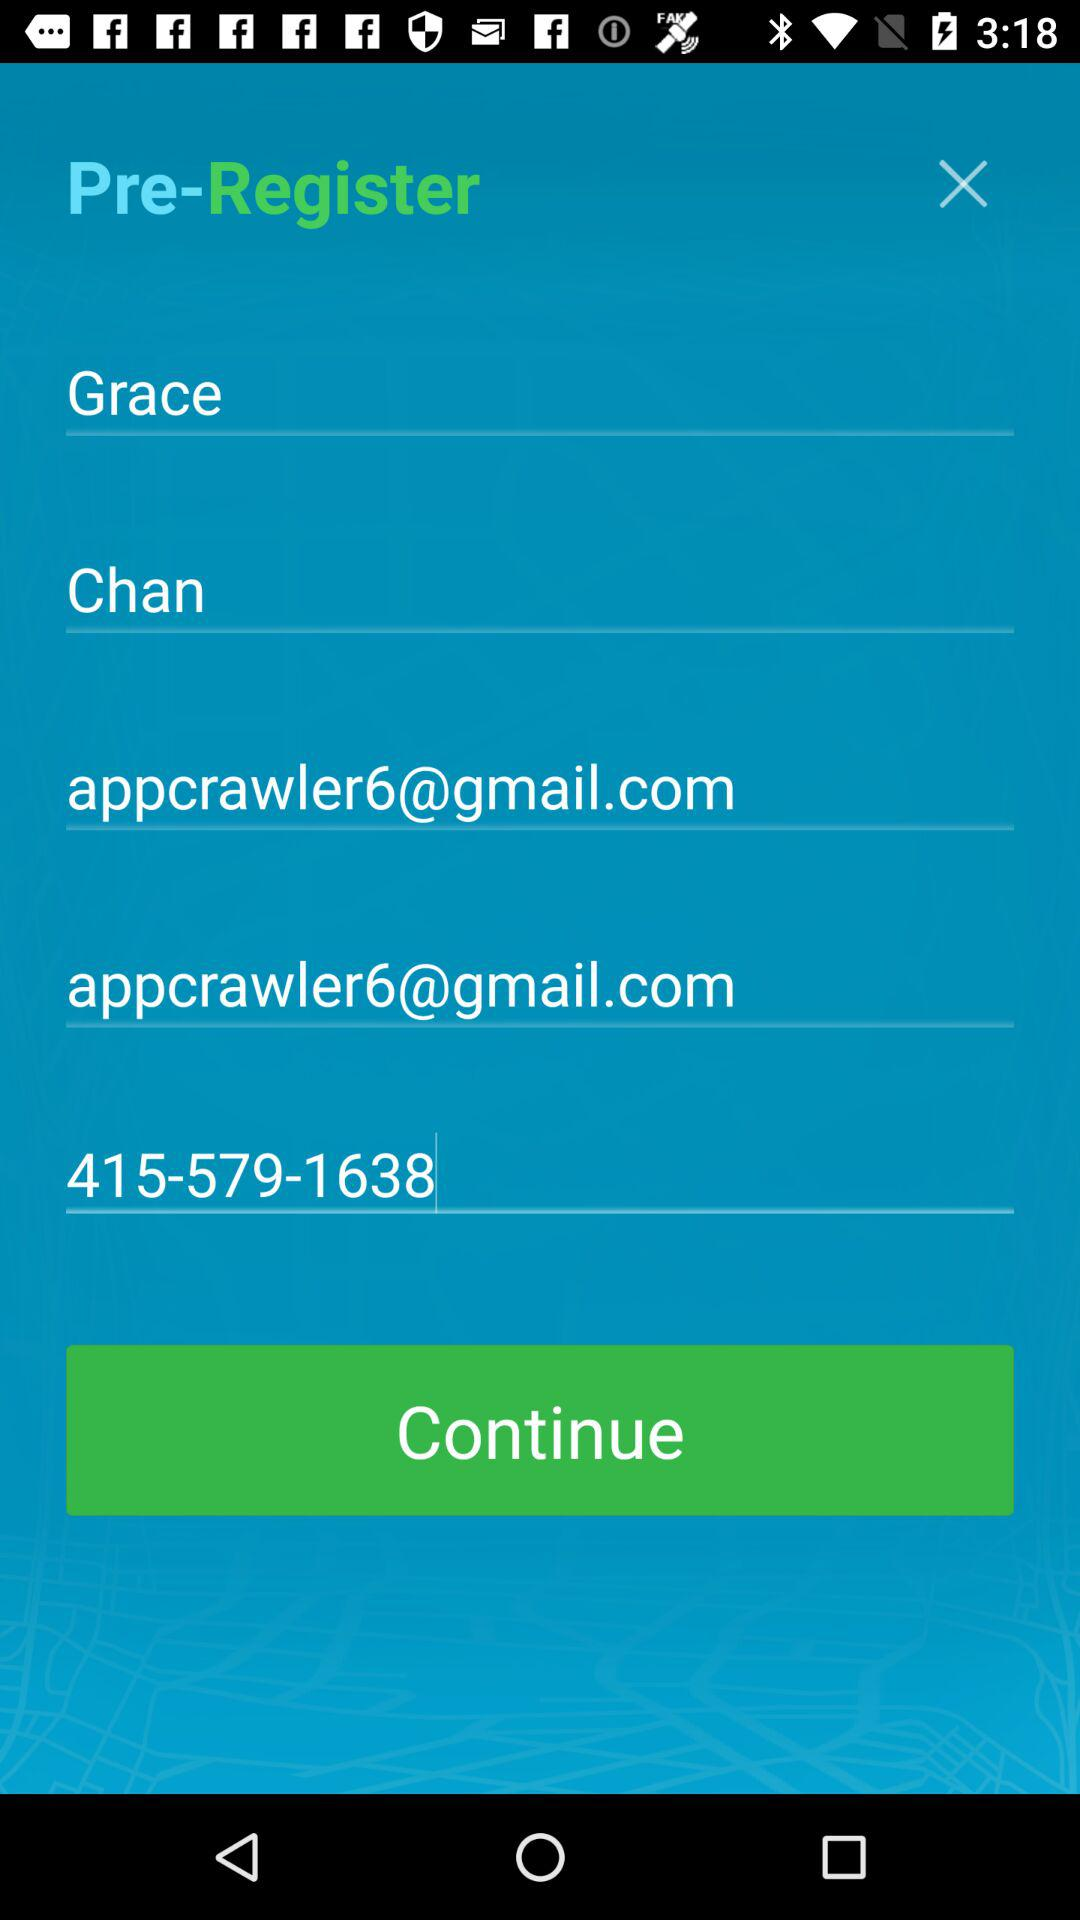What is the email address of the user? The email address of the user is appcrawler6@gmail.com. 